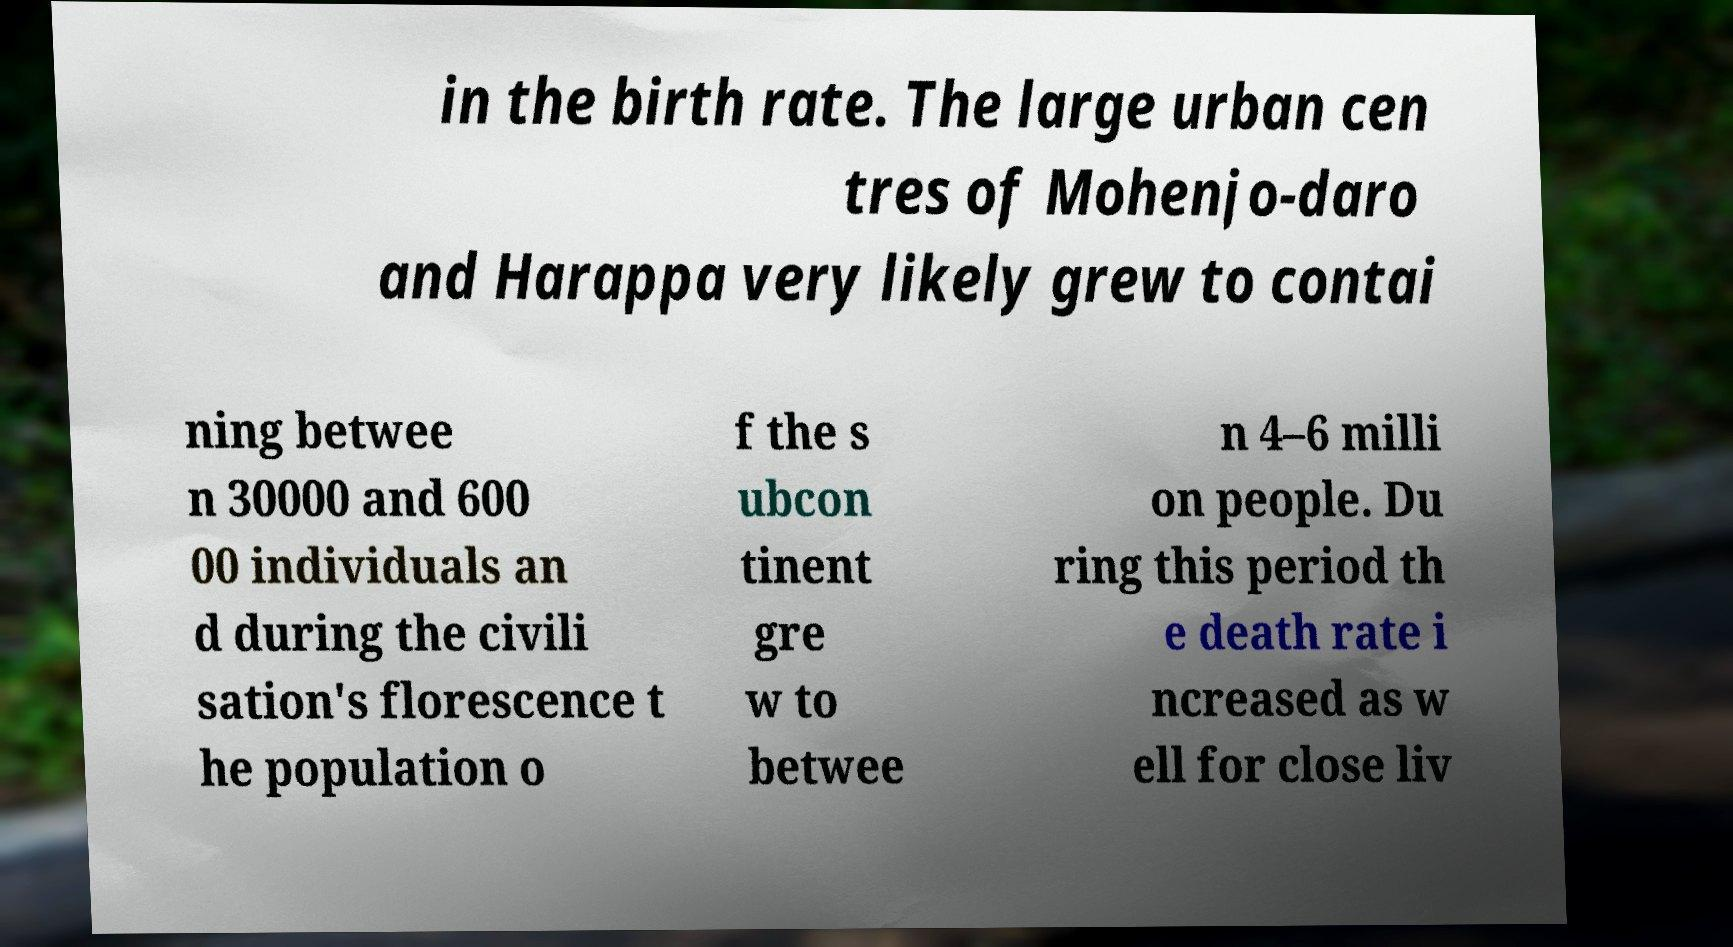Can you accurately transcribe the text from the provided image for me? in the birth rate. The large urban cen tres of Mohenjo-daro and Harappa very likely grew to contai ning betwee n 30000 and 600 00 individuals an d during the civili sation's florescence t he population o f the s ubcon tinent gre w to betwee n 4–6 milli on people. Du ring this period th e death rate i ncreased as w ell for close liv 